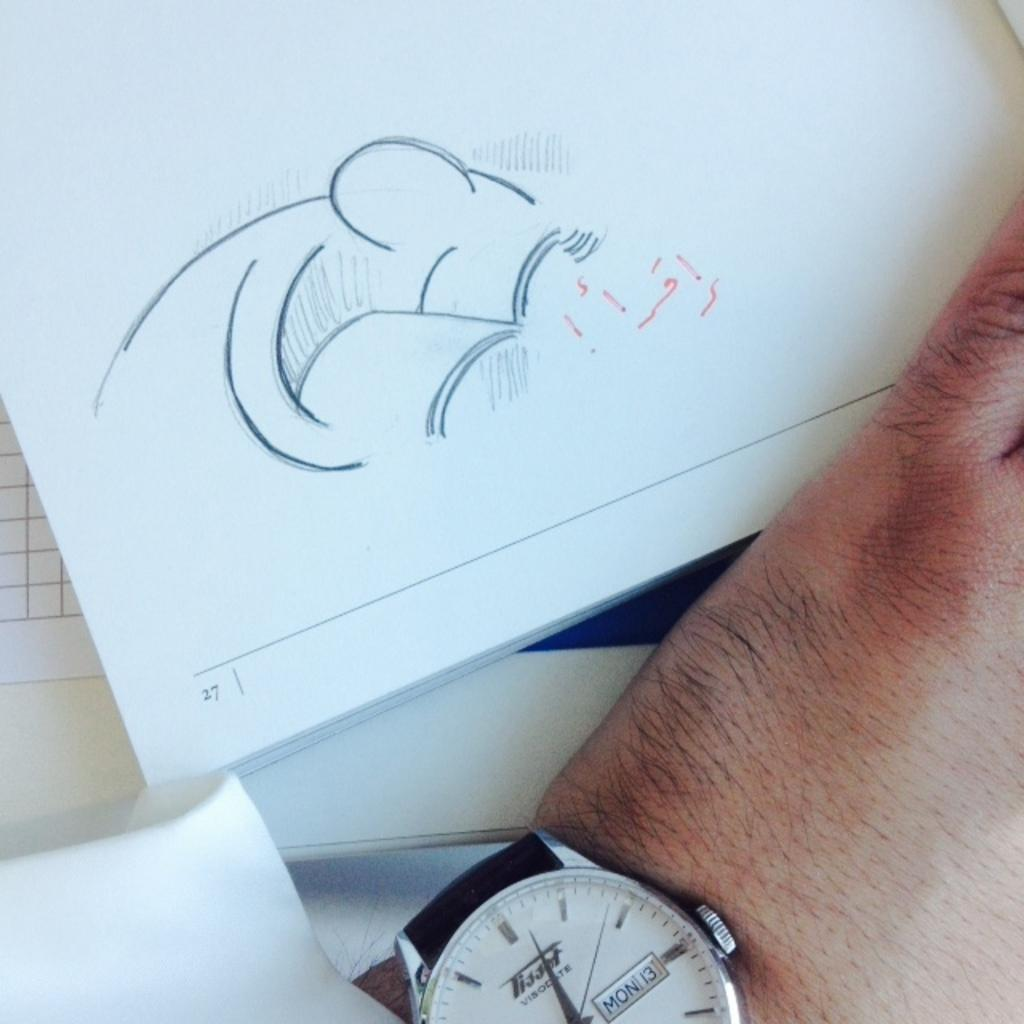<image>
Present a compact description of the photo's key features. A black and gold watch with mon 13 on a person's arm. 